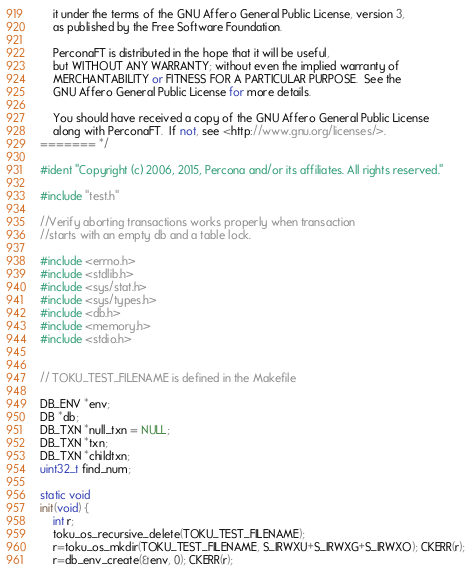<code> <loc_0><loc_0><loc_500><loc_500><_C++_>    it under the terms of the GNU Affero General Public License, version 3,
    as published by the Free Software Foundation.

    PerconaFT is distributed in the hope that it will be useful,
    but WITHOUT ANY WARRANTY; without even the implied warranty of
    MERCHANTABILITY or FITNESS FOR A PARTICULAR PURPOSE.  See the
    GNU Affero General Public License for more details.

    You should have received a copy of the GNU Affero General Public License
    along with PerconaFT.  If not, see <http://www.gnu.org/licenses/>.
======= */

#ident "Copyright (c) 2006, 2015, Percona and/or its affiliates. All rights reserved."

#include "test.h"

//Verify aborting transactions works properly when transaction 
//starts with an empty db and a table lock.

#include <errno.h>
#include <stdlib.h>
#include <sys/stat.h>
#include <sys/types.h>
#include <db.h>
#include <memory.h>
#include <stdio.h>


// TOKU_TEST_FILENAME is defined in the Makefile

DB_ENV *env;
DB *db;
DB_TXN *null_txn = NULL;
DB_TXN *txn;
DB_TXN *childtxn;
uint32_t find_num;

static void
init(void) {
    int r;
    toku_os_recursive_delete(TOKU_TEST_FILENAME);
    r=toku_os_mkdir(TOKU_TEST_FILENAME, S_IRWXU+S_IRWXG+S_IRWXO); CKERR(r);
    r=db_env_create(&env, 0); CKERR(r);</code> 